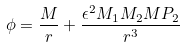Convert formula to latex. <formula><loc_0><loc_0><loc_500><loc_500>\phi = { \frac { M } { r } } + { \frac { \epsilon ^ { 2 } M _ { 1 } M _ { 2 } M P _ { 2 } } { r ^ { 3 } } }</formula> 